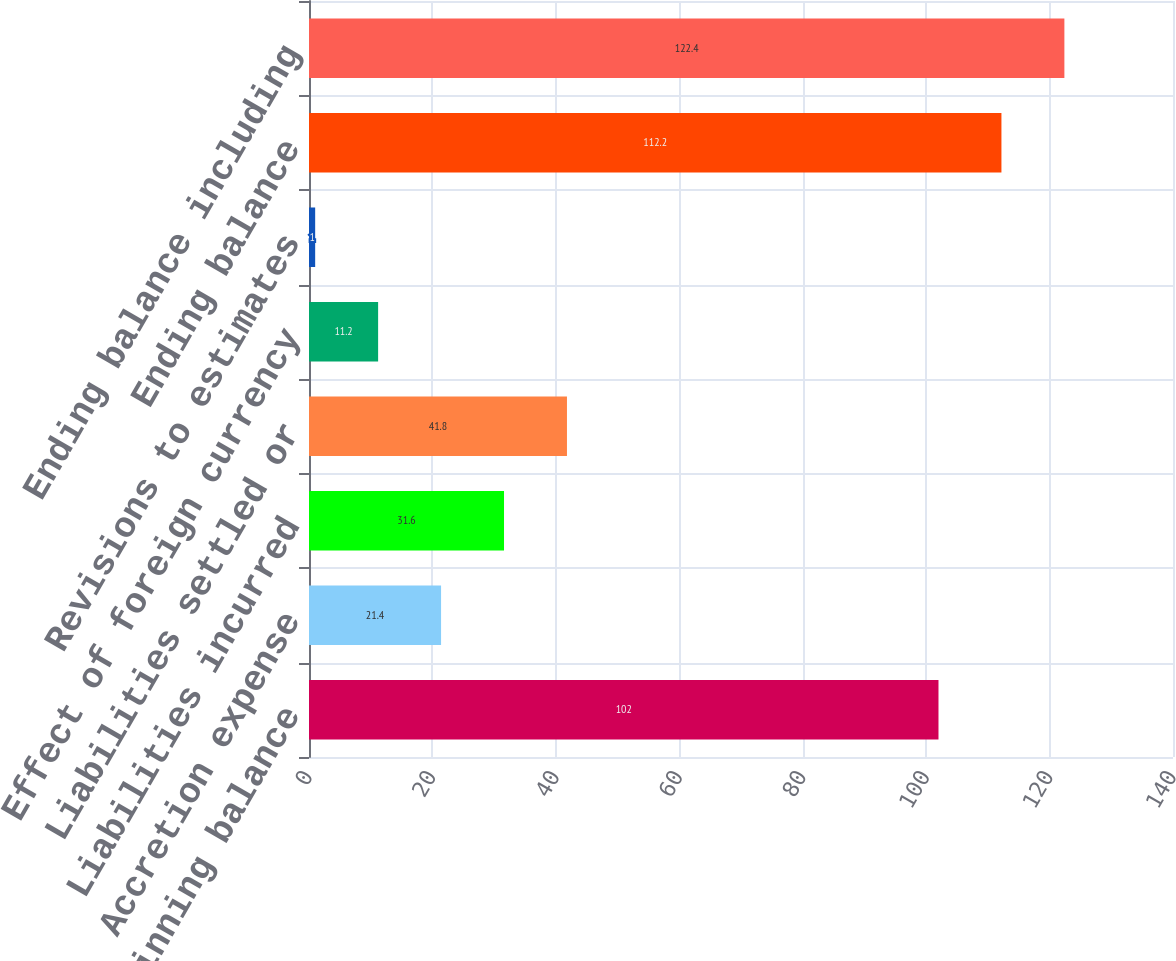Convert chart. <chart><loc_0><loc_0><loc_500><loc_500><bar_chart><fcel>Beginning balance<fcel>Accretion expense<fcel>Liabilities incurred<fcel>Liabilities settled or<fcel>Effect of foreign currency<fcel>Revisions to estimates<fcel>Ending balance<fcel>Ending balance including<nl><fcel>102<fcel>21.4<fcel>31.6<fcel>41.8<fcel>11.2<fcel>1<fcel>112.2<fcel>122.4<nl></chart> 